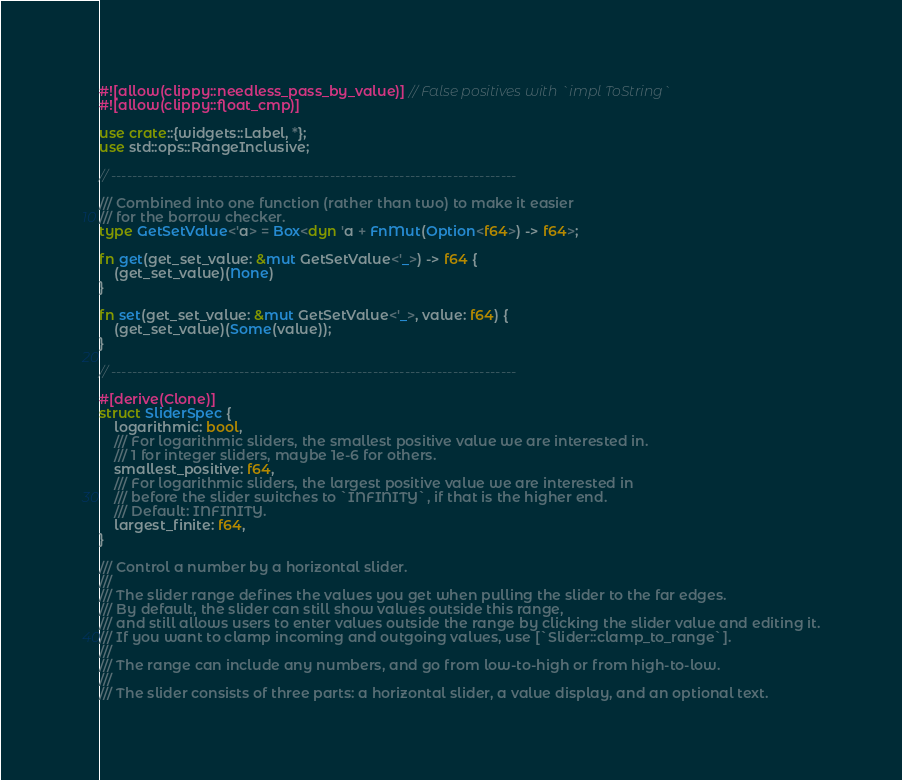<code> <loc_0><loc_0><loc_500><loc_500><_Rust_>#![allow(clippy::needless_pass_by_value)] // False positives with `impl ToString`
#![allow(clippy::float_cmp)]

use crate::{widgets::Label, *};
use std::ops::RangeInclusive;

// ----------------------------------------------------------------------------

/// Combined into one function (rather than two) to make it easier
/// for the borrow checker.
type GetSetValue<'a> = Box<dyn 'a + FnMut(Option<f64>) -> f64>;

fn get(get_set_value: &mut GetSetValue<'_>) -> f64 {
    (get_set_value)(None)
}

fn set(get_set_value: &mut GetSetValue<'_>, value: f64) {
    (get_set_value)(Some(value));
}

// ----------------------------------------------------------------------------

#[derive(Clone)]
struct SliderSpec {
    logarithmic: bool,
    /// For logarithmic sliders, the smallest positive value we are interested in.
    /// 1 for integer sliders, maybe 1e-6 for others.
    smallest_positive: f64,
    /// For logarithmic sliders, the largest positive value we are interested in
    /// before the slider switches to `INFINITY`, if that is the higher end.
    /// Default: INFINITY.
    largest_finite: f64,
}

/// Control a number by a horizontal slider.
///
/// The slider range defines the values you get when pulling the slider to the far edges.
/// By default, the slider can still show values outside this range,
/// and still allows users to enter values outside the range by clicking the slider value and editing it.
/// If you want to clamp incoming and outgoing values, use [`Slider::clamp_to_range`].
///
/// The range can include any numbers, and go from low-to-high or from high-to-low.
///
/// The slider consists of three parts: a horizontal slider, a value display, and an optional text.</code> 